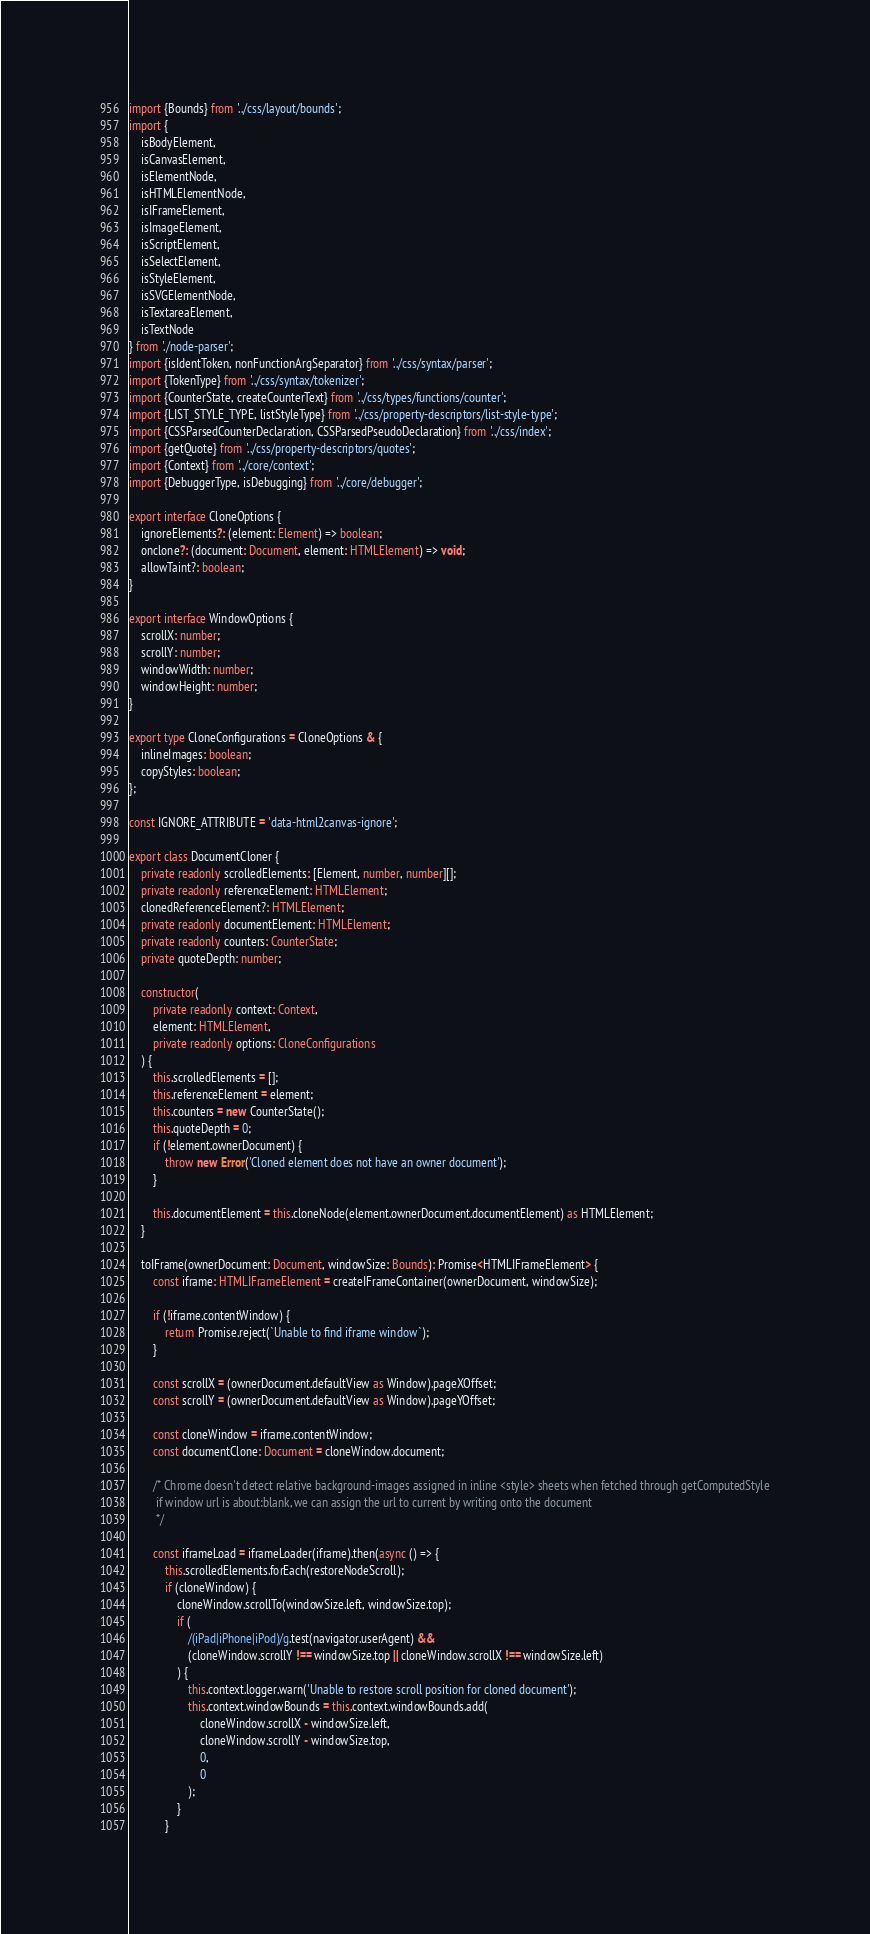Convert code to text. <code><loc_0><loc_0><loc_500><loc_500><_TypeScript_>import {Bounds} from '../css/layout/bounds';
import {
    isBodyElement,
    isCanvasElement,
    isElementNode,
    isHTMLElementNode,
    isIFrameElement,
    isImageElement,
    isScriptElement,
    isSelectElement,
    isStyleElement,
    isSVGElementNode,
    isTextareaElement,
    isTextNode
} from './node-parser';
import {isIdentToken, nonFunctionArgSeparator} from '../css/syntax/parser';
import {TokenType} from '../css/syntax/tokenizer';
import {CounterState, createCounterText} from '../css/types/functions/counter';
import {LIST_STYLE_TYPE, listStyleType} from '../css/property-descriptors/list-style-type';
import {CSSParsedCounterDeclaration, CSSParsedPseudoDeclaration} from '../css/index';
import {getQuote} from '../css/property-descriptors/quotes';
import {Context} from '../core/context';
import {DebuggerType, isDebugging} from '../core/debugger';

export interface CloneOptions {
    ignoreElements?: (element: Element) => boolean;
    onclone?: (document: Document, element: HTMLElement) => void;
    allowTaint?: boolean;
}

export interface WindowOptions {
    scrollX: number;
    scrollY: number;
    windowWidth: number;
    windowHeight: number;
}

export type CloneConfigurations = CloneOptions & {
    inlineImages: boolean;
    copyStyles: boolean;
};

const IGNORE_ATTRIBUTE = 'data-html2canvas-ignore';

export class DocumentCloner {
    private readonly scrolledElements: [Element, number, number][];
    private readonly referenceElement: HTMLElement;
    clonedReferenceElement?: HTMLElement;
    private readonly documentElement: HTMLElement;
    private readonly counters: CounterState;
    private quoteDepth: number;

    constructor(
        private readonly context: Context,
        element: HTMLElement,
        private readonly options: CloneConfigurations
    ) {
        this.scrolledElements = [];
        this.referenceElement = element;
        this.counters = new CounterState();
        this.quoteDepth = 0;
        if (!element.ownerDocument) {
            throw new Error('Cloned element does not have an owner document');
        }

        this.documentElement = this.cloneNode(element.ownerDocument.documentElement) as HTMLElement;
    }

    toIFrame(ownerDocument: Document, windowSize: Bounds): Promise<HTMLIFrameElement> {
        const iframe: HTMLIFrameElement = createIFrameContainer(ownerDocument, windowSize);

        if (!iframe.contentWindow) {
            return Promise.reject(`Unable to find iframe window`);
        }

        const scrollX = (ownerDocument.defaultView as Window).pageXOffset;
        const scrollY = (ownerDocument.defaultView as Window).pageYOffset;

        const cloneWindow = iframe.contentWindow;
        const documentClone: Document = cloneWindow.document;

        /* Chrome doesn't detect relative background-images assigned in inline <style> sheets when fetched through getComputedStyle
         if window url is about:blank, we can assign the url to current by writing onto the document
         */

        const iframeLoad = iframeLoader(iframe).then(async () => {
            this.scrolledElements.forEach(restoreNodeScroll);
            if (cloneWindow) {
                cloneWindow.scrollTo(windowSize.left, windowSize.top);
                if (
                    /(iPad|iPhone|iPod)/g.test(navigator.userAgent) &&
                    (cloneWindow.scrollY !== windowSize.top || cloneWindow.scrollX !== windowSize.left)
                ) {
                    this.context.logger.warn('Unable to restore scroll position for cloned document');
                    this.context.windowBounds = this.context.windowBounds.add(
                        cloneWindow.scrollX - windowSize.left,
                        cloneWindow.scrollY - windowSize.top,
                        0,
                        0
                    );
                }
            }
</code> 